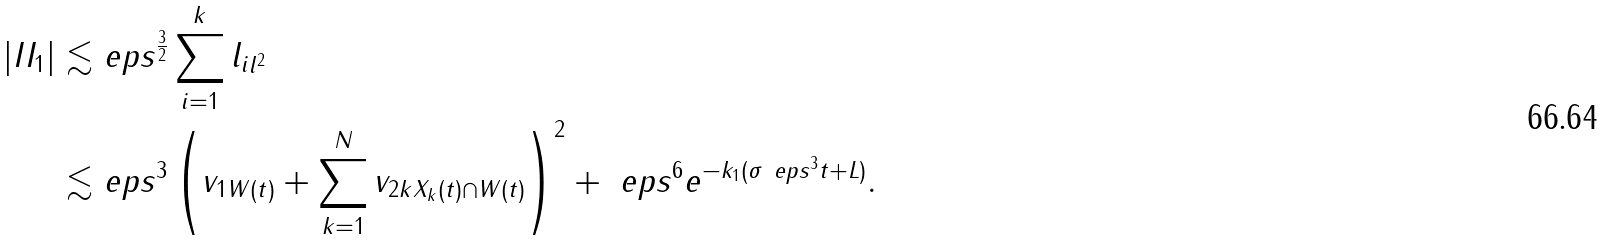Convert formula to latex. <formula><loc_0><loc_0><loc_500><loc_500>| I I _ { 1 } | \lesssim & \ e p s ^ { \frac { 3 } { 2 } } \sum _ { i = 1 } ^ { k } \| l _ { i } \| _ { l ^ { 2 } } \\ \lesssim & \ e p s ^ { 3 } \left ( \| v _ { 1 } \| _ { W ( t ) } + \sum _ { k = 1 } ^ { N } \| v _ { 2 k } \| _ { X _ { k } ( t ) \cap W ( t ) } \right ) ^ { 2 } + \ e p s ^ { 6 } e ^ { - k _ { 1 } ( \sigma \ e p s ^ { 3 } t + L ) } .</formula> 